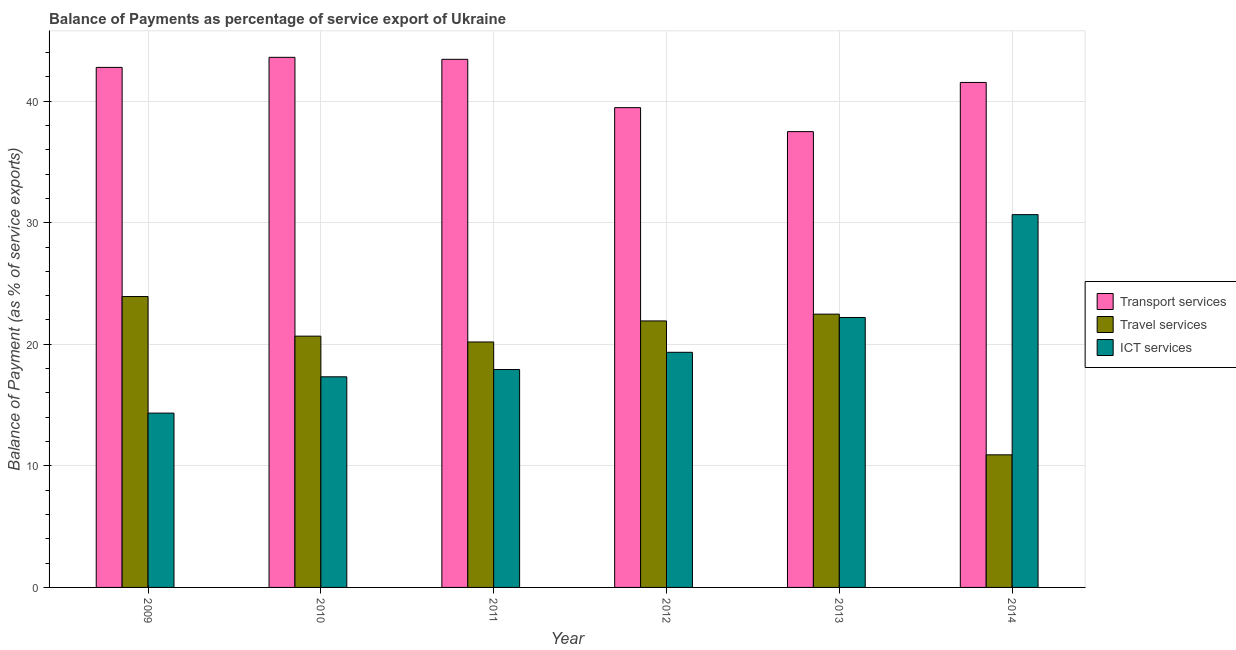How many different coloured bars are there?
Your answer should be very brief. 3. How many groups of bars are there?
Your answer should be very brief. 6. Are the number of bars per tick equal to the number of legend labels?
Offer a very short reply. Yes. How many bars are there on the 4th tick from the right?
Provide a short and direct response. 3. What is the label of the 6th group of bars from the left?
Your answer should be very brief. 2014. What is the balance of payment of travel services in 2014?
Offer a terse response. 10.91. Across all years, what is the maximum balance of payment of travel services?
Your response must be concise. 23.93. Across all years, what is the minimum balance of payment of ict services?
Offer a very short reply. 14.34. What is the total balance of payment of ict services in the graph?
Offer a very short reply. 121.79. What is the difference between the balance of payment of ict services in 2012 and that in 2013?
Your answer should be compact. -2.86. What is the difference between the balance of payment of transport services in 2014 and the balance of payment of travel services in 2009?
Ensure brevity in your answer.  -1.24. What is the average balance of payment of ict services per year?
Your answer should be compact. 20.3. In the year 2013, what is the difference between the balance of payment of travel services and balance of payment of transport services?
Offer a terse response. 0. What is the ratio of the balance of payment of travel services in 2012 to that in 2014?
Offer a very short reply. 2.01. Is the balance of payment of ict services in 2009 less than that in 2012?
Offer a very short reply. Yes. Is the difference between the balance of payment of travel services in 2011 and 2013 greater than the difference between the balance of payment of ict services in 2011 and 2013?
Keep it short and to the point. No. What is the difference between the highest and the second highest balance of payment of transport services?
Provide a succinct answer. 0.16. What is the difference between the highest and the lowest balance of payment of travel services?
Make the answer very short. 13.02. What does the 2nd bar from the left in 2012 represents?
Your response must be concise. Travel services. What does the 2nd bar from the right in 2014 represents?
Your answer should be very brief. Travel services. Is it the case that in every year, the sum of the balance of payment of transport services and balance of payment of travel services is greater than the balance of payment of ict services?
Ensure brevity in your answer.  Yes. How many bars are there?
Your answer should be very brief. 18. Are all the bars in the graph horizontal?
Provide a short and direct response. No. How many years are there in the graph?
Your answer should be compact. 6. What is the difference between two consecutive major ticks on the Y-axis?
Your answer should be very brief. 10. Are the values on the major ticks of Y-axis written in scientific E-notation?
Ensure brevity in your answer.  No. Does the graph contain any zero values?
Your answer should be very brief. No. Does the graph contain grids?
Offer a terse response. Yes. How many legend labels are there?
Offer a very short reply. 3. How are the legend labels stacked?
Your answer should be very brief. Vertical. What is the title of the graph?
Give a very brief answer. Balance of Payments as percentage of service export of Ukraine. Does "Financial account" appear as one of the legend labels in the graph?
Give a very brief answer. No. What is the label or title of the Y-axis?
Offer a terse response. Balance of Payment (as % of service exports). What is the Balance of Payment (as % of service exports) in Transport services in 2009?
Your answer should be very brief. 42.77. What is the Balance of Payment (as % of service exports) of Travel services in 2009?
Offer a terse response. 23.93. What is the Balance of Payment (as % of service exports) of ICT services in 2009?
Your response must be concise. 14.34. What is the Balance of Payment (as % of service exports) of Transport services in 2010?
Make the answer very short. 43.6. What is the Balance of Payment (as % of service exports) in Travel services in 2010?
Give a very brief answer. 20.67. What is the Balance of Payment (as % of service exports) of ICT services in 2010?
Ensure brevity in your answer.  17.32. What is the Balance of Payment (as % of service exports) of Transport services in 2011?
Keep it short and to the point. 43.44. What is the Balance of Payment (as % of service exports) in Travel services in 2011?
Provide a short and direct response. 20.19. What is the Balance of Payment (as % of service exports) in ICT services in 2011?
Offer a terse response. 17.92. What is the Balance of Payment (as % of service exports) of Transport services in 2012?
Your response must be concise. 39.46. What is the Balance of Payment (as % of service exports) in Travel services in 2012?
Keep it short and to the point. 21.92. What is the Balance of Payment (as % of service exports) in ICT services in 2012?
Keep it short and to the point. 19.34. What is the Balance of Payment (as % of service exports) in Transport services in 2013?
Your answer should be very brief. 37.49. What is the Balance of Payment (as % of service exports) in Travel services in 2013?
Give a very brief answer. 22.48. What is the Balance of Payment (as % of service exports) of ICT services in 2013?
Offer a very short reply. 22.2. What is the Balance of Payment (as % of service exports) of Transport services in 2014?
Offer a very short reply. 41.54. What is the Balance of Payment (as % of service exports) of Travel services in 2014?
Give a very brief answer. 10.91. What is the Balance of Payment (as % of service exports) in ICT services in 2014?
Your answer should be very brief. 30.66. Across all years, what is the maximum Balance of Payment (as % of service exports) in Transport services?
Your answer should be very brief. 43.6. Across all years, what is the maximum Balance of Payment (as % of service exports) of Travel services?
Offer a terse response. 23.93. Across all years, what is the maximum Balance of Payment (as % of service exports) of ICT services?
Give a very brief answer. 30.66. Across all years, what is the minimum Balance of Payment (as % of service exports) of Transport services?
Offer a terse response. 37.49. Across all years, what is the minimum Balance of Payment (as % of service exports) in Travel services?
Give a very brief answer. 10.91. Across all years, what is the minimum Balance of Payment (as % of service exports) in ICT services?
Provide a short and direct response. 14.34. What is the total Balance of Payment (as % of service exports) in Transport services in the graph?
Your answer should be compact. 248.31. What is the total Balance of Payment (as % of service exports) of Travel services in the graph?
Offer a terse response. 120.09. What is the total Balance of Payment (as % of service exports) in ICT services in the graph?
Your answer should be compact. 121.79. What is the difference between the Balance of Payment (as % of service exports) in Transport services in 2009 and that in 2010?
Offer a terse response. -0.83. What is the difference between the Balance of Payment (as % of service exports) in Travel services in 2009 and that in 2010?
Give a very brief answer. 3.26. What is the difference between the Balance of Payment (as % of service exports) in ICT services in 2009 and that in 2010?
Offer a terse response. -2.99. What is the difference between the Balance of Payment (as % of service exports) of Transport services in 2009 and that in 2011?
Your answer should be very brief. -0.66. What is the difference between the Balance of Payment (as % of service exports) in Travel services in 2009 and that in 2011?
Keep it short and to the point. 3.74. What is the difference between the Balance of Payment (as % of service exports) of ICT services in 2009 and that in 2011?
Your answer should be compact. -3.58. What is the difference between the Balance of Payment (as % of service exports) in Transport services in 2009 and that in 2012?
Provide a short and direct response. 3.31. What is the difference between the Balance of Payment (as % of service exports) of Travel services in 2009 and that in 2012?
Your response must be concise. 2.01. What is the difference between the Balance of Payment (as % of service exports) of ICT services in 2009 and that in 2012?
Ensure brevity in your answer.  -5. What is the difference between the Balance of Payment (as % of service exports) in Transport services in 2009 and that in 2013?
Offer a terse response. 5.28. What is the difference between the Balance of Payment (as % of service exports) in Travel services in 2009 and that in 2013?
Make the answer very short. 1.45. What is the difference between the Balance of Payment (as % of service exports) of ICT services in 2009 and that in 2013?
Ensure brevity in your answer.  -7.87. What is the difference between the Balance of Payment (as % of service exports) of Transport services in 2009 and that in 2014?
Offer a terse response. 1.24. What is the difference between the Balance of Payment (as % of service exports) of Travel services in 2009 and that in 2014?
Give a very brief answer. 13.02. What is the difference between the Balance of Payment (as % of service exports) in ICT services in 2009 and that in 2014?
Your answer should be compact. -16.32. What is the difference between the Balance of Payment (as % of service exports) of Transport services in 2010 and that in 2011?
Provide a short and direct response. 0.16. What is the difference between the Balance of Payment (as % of service exports) of Travel services in 2010 and that in 2011?
Ensure brevity in your answer.  0.48. What is the difference between the Balance of Payment (as % of service exports) in ICT services in 2010 and that in 2011?
Give a very brief answer. -0.6. What is the difference between the Balance of Payment (as % of service exports) of Transport services in 2010 and that in 2012?
Your answer should be very brief. 4.14. What is the difference between the Balance of Payment (as % of service exports) in Travel services in 2010 and that in 2012?
Offer a very short reply. -1.25. What is the difference between the Balance of Payment (as % of service exports) of ICT services in 2010 and that in 2012?
Your response must be concise. -2.02. What is the difference between the Balance of Payment (as % of service exports) in Transport services in 2010 and that in 2013?
Provide a succinct answer. 6.11. What is the difference between the Balance of Payment (as % of service exports) in Travel services in 2010 and that in 2013?
Your answer should be very brief. -1.81. What is the difference between the Balance of Payment (as % of service exports) of ICT services in 2010 and that in 2013?
Your response must be concise. -4.88. What is the difference between the Balance of Payment (as % of service exports) of Transport services in 2010 and that in 2014?
Keep it short and to the point. 2.07. What is the difference between the Balance of Payment (as % of service exports) in Travel services in 2010 and that in 2014?
Keep it short and to the point. 9.76. What is the difference between the Balance of Payment (as % of service exports) of ICT services in 2010 and that in 2014?
Offer a very short reply. -13.34. What is the difference between the Balance of Payment (as % of service exports) of Transport services in 2011 and that in 2012?
Make the answer very short. 3.98. What is the difference between the Balance of Payment (as % of service exports) of Travel services in 2011 and that in 2012?
Ensure brevity in your answer.  -1.73. What is the difference between the Balance of Payment (as % of service exports) of ICT services in 2011 and that in 2012?
Offer a very short reply. -1.42. What is the difference between the Balance of Payment (as % of service exports) in Transport services in 2011 and that in 2013?
Make the answer very short. 5.95. What is the difference between the Balance of Payment (as % of service exports) in Travel services in 2011 and that in 2013?
Give a very brief answer. -2.29. What is the difference between the Balance of Payment (as % of service exports) in ICT services in 2011 and that in 2013?
Give a very brief answer. -4.28. What is the difference between the Balance of Payment (as % of service exports) of Transport services in 2011 and that in 2014?
Offer a terse response. 1.9. What is the difference between the Balance of Payment (as % of service exports) of Travel services in 2011 and that in 2014?
Keep it short and to the point. 9.28. What is the difference between the Balance of Payment (as % of service exports) in ICT services in 2011 and that in 2014?
Offer a terse response. -12.74. What is the difference between the Balance of Payment (as % of service exports) in Transport services in 2012 and that in 2013?
Ensure brevity in your answer.  1.97. What is the difference between the Balance of Payment (as % of service exports) of Travel services in 2012 and that in 2013?
Your answer should be compact. -0.56. What is the difference between the Balance of Payment (as % of service exports) in ICT services in 2012 and that in 2013?
Offer a very short reply. -2.86. What is the difference between the Balance of Payment (as % of service exports) of Transport services in 2012 and that in 2014?
Your answer should be very brief. -2.07. What is the difference between the Balance of Payment (as % of service exports) of Travel services in 2012 and that in 2014?
Offer a very short reply. 11.01. What is the difference between the Balance of Payment (as % of service exports) in ICT services in 2012 and that in 2014?
Your answer should be compact. -11.32. What is the difference between the Balance of Payment (as % of service exports) of Transport services in 2013 and that in 2014?
Keep it short and to the point. -4.04. What is the difference between the Balance of Payment (as % of service exports) of Travel services in 2013 and that in 2014?
Offer a very short reply. 11.57. What is the difference between the Balance of Payment (as % of service exports) of ICT services in 2013 and that in 2014?
Your answer should be very brief. -8.46. What is the difference between the Balance of Payment (as % of service exports) of Transport services in 2009 and the Balance of Payment (as % of service exports) of Travel services in 2010?
Your answer should be compact. 22.11. What is the difference between the Balance of Payment (as % of service exports) of Transport services in 2009 and the Balance of Payment (as % of service exports) of ICT services in 2010?
Give a very brief answer. 25.45. What is the difference between the Balance of Payment (as % of service exports) in Travel services in 2009 and the Balance of Payment (as % of service exports) in ICT services in 2010?
Offer a very short reply. 6.6. What is the difference between the Balance of Payment (as % of service exports) of Transport services in 2009 and the Balance of Payment (as % of service exports) of Travel services in 2011?
Keep it short and to the point. 22.59. What is the difference between the Balance of Payment (as % of service exports) of Transport services in 2009 and the Balance of Payment (as % of service exports) of ICT services in 2011?
Keep it short and to the point. 24.85. What is the difference between the Balance of Payment (as % of service exports) in Travel services in 2009 and the Balance of Payment (as % of service exports) in ICT services in 2011?
Your answer should be compact. 6. What is the difference between the Balance of Payment (as % of service exports) in Transport services in 2009 and the Balance of Payment (as % of service exports) in Travel services in 2012?
Make the answer very short. 20.85. What is the difference between the Balance of Payment (as % of service exports) in Transport services in 2009 and the Balance of Payment (as % of service exports) in ICT services in 2012?
Provide a short and direct response. 23.43. What is the difference between the Balance of Payment (as % of service exports) of Travel services in 2009 and the Balance of Payment (as % of service exports) of ICT services in 2012?
Your answer should be very brief. 4.59. What is the difference between the Balance of Payment (as % of service exports) of Transport services in 2009 and the Balance of Payment (as % of service exports) of Travel services in 2013?
Offer a very short reply. 20.3. What is the difference between the Balance of Payment (as % of service exports) of Transport services in 2009 and the Balance of Payment (as % of service exports) of ICT services in 2013?
Give a very brief answer. 20.57. What is the difference between the Balance of Payment (as % of service exports) in Travel services in 2009 and the Balance of Payment (as % of service exports) in ICT services in 2013?
Give a very brief answer. 1.72. What is the difference between the Balance of Payment (as % of service exports) in Transport services in 2009 and the Balance of Payment (as % of service exports) in Travel services in 2014?
Offer a very short reply. 31.87. What is the difference between the Balance of Payment (as % of service exports) in Transport services in 2009 and the Balance of Payment (as % of service exports) in ICT services in 2014?
Ensure brevity in your answer.  12.11. What is the difference between the Balance of Payment (as % of service exports) in Travel services in 2009 and the Balance of Payment (as % of service exports) in ICT services in 2014?
Your answer should be very brief. -6.74. What is the difference between the Balance of Payment (as % of service exports) of Transport services in 2010 and the Balance of Payment (as % of service exports) of Travel services in 2011?
Offer a very short reply. 23.41. What is the difference between the Balance of Payment (as % of service exports) of Transport services in 2010 and the Balance of Payment (as % of service exports) of ICT services in 2011?
Your answer should be very brief. 25.68. What is the difference between the Balance of Payment (as % of service exports) of Travel services in 2010 and the Balance of Payment (as % of service exports) of ICT services in 2011?
Your answer should be compact. 2.75. What is the difference between the Balance of Payment (as % of service exports) in Transport services in 2010 and the Balance of Payment (as % of service exports) in Travel services in 2012?
Provide a short and direct response. 21.68. What is the difference between the Balance of Payment (as % of service exports) of Transport services in 2010 and the Balance of Payment (as % of service exports) of ICT services in 2012?
Offer a very short reply. 24.26. What is the difference between the Balance of Payment (as % of service exports) in Travel services in 2010 and the Balance of Payment (as % of service exports) in ICT services in 2012?
Your answer should be compact. 1.33. What is the difference between the Balance of Payment (as % of service exports) of Transport services in 2010 and the Balance of Payment (as % of service exports) of Travel services in 2013?
Offer a very short reply. 21.12. What is the difference between the Balance of Payment (as % of service exports) of Transport services in 2010 and the Balance of Payment (as % of service exports) of ICT services in 2013?
Provide a succinct answer. 21.4. What is the difference between the Balance of Payment (as % of service exports) of Travel services in 2010 and the Balance of Payment (as % of service exports) of ICT services in 2013?
Ensure brevity in your answer.  -1.54. What is the difference between the Balance of Payment (as % of service exports) of Transport services in 2010 and the Balance of Payment (as % of service exports) of Travel services in 2014?
Ensure brevity in your answer.  32.7. What is the difference between the Balance of Payment (as % of service exports) of Transport services in 2010 and the Balance of Payment (as % of service exports) of ICT services in 2014?
Provide a short and direct response. 12.94. What is the difference between the Balance of Payment (as % of service exports) of Travel services in 2010 and the Balance of Payment (as % of service exports) of ICT services in 2014?
Provide a succinct answer. -9.99. What is the difference between the Balance of Payment (as % of service exports) of Transport services in 2011 and the Balance of Payment (as % of service exports) of Travel services in 2012?
Ensure brevity in your answer.  21.52. What is the difference between the Balance of Payment (as % of service exports) in Transport services in 2011 and the Balance of Payment (as % of service exports) in ICT services in 2012?
Give a very brief answer. 24.1. What is the difference between the Balance of Payment (as % of service exports) of Travel services in 2011 and the Balance of Payment (as % of service exports) of ICT services in 2012?
Ensure brevity in your answer.  0.85. What is the difference between the Balance of Payment (as % of service exports) of Transport services in 2011 and the Balance of Payment (as % of service exports) of Travel services in 2013?
Provide a short and direct response. 20.96. What is the difference between the Balance of Payment (as % of service exports) in Transport services in 2011 and the Balance of Payment (as % of service exports) in ICT services in 2013?
Offer a terse response. 21.23. What is the difference between the Balance of Payment (as % of service exports) in Travel services in 2011 and the Balance of Payment (as % of service exports) in ICT services in 2013?
Provide a short and direct response. -2.02. What is the difference between the Balance of Payment (as % of service exports) in Transport services in 2011 and the Balance of Payment (as % of service exports) in Travel services in 2014?
Your answer should be compact. 32.53. What is the difference between the Balance of Payment (as % of service exports) of Transport services in 2011 and the Balance of Payment (as % of service exports) of ICT services in 2014?
Make the answer very short. 12.78. What is the difference between the Balance of Payment (as % of service exports) of Travel services in 2011 and the Balance of Payment (as % of service exports) of ICT services in 2014?
Provide a succinct answer. -10.47. What is the difference between the Balance of Payment (as % of service exports) of Transport services in 2012 and the Balance of Payment (as % of service exports) of Travel services in 2013?
Give a very brief answer. 16.98. What is the difference between the Balance of Payment (as % of service exports) of Transport services in 2012 and the Balance of Payment (as % of service exports) of ICT services in 2013?
Offer a very short reply. 17.26. What is the difference between the Balance of Payment (as % of service exports) of Travel services in 2012 and the Balance of Payment (as % of service exports) of ICT services in 2013?
Keep it short and to the point. -0.28. What is the difference between the Balance of Payment (as % of service exports) of Transport services in 2012 and the Balance of Payment (as % of service exports) of Travel services in 2014?
Give a very brief answer. 28.56. What is the difference between the Balance of Payment (as % of service exports) of Transport services in 2012 and the Balance of Payment (as % of service exports) of ICT services in 2014?
Offer a terse response. 8.8. What is the difference between the Balance of Payment (as % of service exports) in Travel services in 2012 and the Balance of Payment (as % of service exports) in ICT services in 2014?
Provide a succinct answer. -8.74. What is the difference between the Balance of Payment (as % of service exports) of Transport services in 2013 and the Balance of Payment (as % of service exports) of Travel services in 2014?
Offer a terse response. 26.59. What is the difference between the Balance of Payment (as % of service exports) in Transport services in 2013 and the Balance of Payment (as % of service exports) in ICT services in 2014?
Ensure brevity in your answer.  6.83. What is the difference between the Balance of Payment (as % of service exports) of Travel services in 2013 and the Balance of Payment (as % of service exports) of ICT services in 2014?
Offer a very short reply. -8.18. What is the average Balance of Payment (as % of service exports) in Transport services per year?
Keep it short and to the point. 41.38. What is the average Balance of Payment (as % of service exports) in Travel services per year?
Your answer should be very brief. 20.01. What is the average Balance of Payment (as % of service exports) of ICT services per year?
Your response must be concise. 20.3. In the year 2009, what is the difference between the Balance of Payment (as % of service exports) of Transport services and Balance of Payment (as % of service exports) of Travel services?
Keep it short and to the point. 18.85. In the year 2009, what is the difference between the Balance of Payment (as % of service exports) of Transport services and Balance of Payment (as % of service exports) of ICT services?
Provide a short and direct response. 28.44. In the year 2009, what is the difference between the Balance of Payment (as % of service exports) of Travel services and Balance of Payment (as % of service exports) of ICT services?
Ensure brevity in your answer.  9.59. In the year 2010, what is the difference between the Balance of Payment (as % of service exports) of Transport services and Balance of Payment (as % of service exports) of Travel services?
Ensure brevity in your answer.  22.93. In the year 2010, what is the difference between the Balance of Payment (as % of service exports) in Transport services and Balance of Payment (as % of service exports) in ICT services?
Give a very brief answer. 26.28. In the year 2010, what is the difference between the Balance of Payment (as % of service exports) of Travel services and Balance of Payment (as % of service exports) of ICT services?
Your response must be concise. 3.34. In the year 2011, what is the difference between the Balance of Payment (as % of service exports) of Transport services and Balance of Payment (as % of service exports) of Travel services?
Your answer should be very brief. 23.25. In the year 2011, what is the difference between the Balance of Payment (as % of service exports) of Transport services and Balance of Payment (as % of service exports) of ICT services?
Offer a very short reply. 25.52. In the year 2011, what is the difference between the Balance of Payment (as % of service exports) of Travel services and Balance of Payment (as % of service exports) of ICT services?
Provide a succinct answer. 2.27. In the year 2012, what is the difference between the Balance of Payment (as % of service exports) in Transport services and Balance of Payment (as % of service exports) in Travel services?
Make the answer very short. 17.54. In the year 2012, what is the difference between the Balance of Payment (as % of service exports) of Transport services and Balance of Payment (as % of service exports) of ICT services?
Your answer should be compact. 20.12. In the year 2012, what is the difference between the Balance of Payment (as % of service exports) of Travel services and Balance of Payment (as % of service exports) of ICT services?
Provide a succinct answer. 2.58. In the year 2013, what is the difference between the Balance of Payment (as % of service exports) of Transport services and Balance of Payment (as % of service exports) of Travel services?
Give a very brief answer. 15.01. In the year 2013, what is the difference between the Balance of Payment (as % of service exports) of Transport services and Balance of Payment (as % of service exports) of ICT services?
Keep it short and to the point. 15.29. In the year 2013, what is the difference between the Balance of Payment (as % of service exports) of Travel services and Balance of Payment (as % of service exports) of ICT services?
Keep it short and to the point. 0.27. In the year 2014, what is the difference between the Balance of Payment (as % of service exports) of Transport services and Balance of Payment (as % of service exports) of Travel services?
Your response must be concise. 30.63. In the year 2014, what is the difference between the Balance of Payment (as % of service exports) in Transport services and Balance of Payment (as % of service exports) in ICT services?
Give a very brief answer. 10.87. In the year 2014, what is the difference between the Balance of Payment (as % of service exports) in Travel services and Balance of Payment (as % of service exports) in ICT services?
Your response must be concise. -19.76. What is the ratio of the Balance of Payment (as % of service exports) in Transport services in 2009 to that in 2010?
Offer a very short reply. 0.98. What is the ratio of the Balance of Payment (as % of service exports) of Travel services in 2009 to that in 2010?
Keep it short and to the point. 1.16. What is the ratio of the Balance of Payment (as % of service exports) of ICT services in 2009 to that in 2010?
Make the answer very short. 0.83. What is the ratio of the Balance of Payment (as % of service exports) of Transport services in 2009 to that in 2011?
Make the answer very short. 0.98. What is the ratio of the Balance of Payment (as % of service exports) of Travel services in 2009 to that in 2011?
Offer a very short reply. 1.19. What is the ratio of the Balance of Payment (as % of service exports) in Transport services in 2009 to that in 2012?
Make the answer very short. 1.08. What is the ratio of the Balance of Payment (as % of service exports) in Travel services in 2009 to that in 2012?
Give a very brief answer. 1.09. What is the ratio of the Balance of Payment (as % of service exports) of ICT services in 2009 to that in 2012?
Provide a succinct answer. 0.74. What is the ratio of the Balance of Payment (as % of service exports) in Transport services in 2009 to that in 2013?
Your response must be concise. 1.14. What is the ratio of the Balance of Payment (as % of service exports) in Travel services in 2009 to that in 2013?
Give a very brief answer. 1.06. What is the ratio of the Balance of Payment (as % of service exports) in ICT services in 2009 to that in 2013?
Your answer should be very brief. 0.65. What is the ratio of the Balance of Payment (as % of service exports) of Transport services in 2009 to that in 2014?
Ensure brevity in your answer.  1.03. What is the ratio of the Balance of Payment (as % of service exports) of Travel services in 2009 to that in 2014?
Your answer should be compact. 2.19. What is the ratio of the Balance of Payment (as % of service exports) in ICT services in 2009 to that in 2014?
Provide a succinct answer. 0.47. What is the ratio of the Balance of Payment (as % of service exports) in Travel services in 2010 to that in 2011?
Your answer should be compact. 1.02. What is the ratio of the Balance of Payment (as % of service exports) in ICT services in 2010 to that in 2011?
Give a very brief answer. 0.97. What is the ratio of the Balance of Payment (as % of service exports) of Transport services in 2010 to that in 2012?
Your response must be concise. 1.1. What is the ratio of the Balance of Payment (as % of service exports) of Travel services in 2010 to that in 2012?
Your answer should be compact. 0.94. What is the ratio of the Balance of Payment (as % of service exports) in ICT services in 2010 to that in 2012?
Your response must be concise. 0.9. What is the ratio of the Balance of Payment (as % of service exports) of Transport services in 2010 to that in 2013?
Offer a very short reply. 1.16. What is the ratio of the Balance of Payment (as % of service exports) of Travel services in 2010 to that in 2013?
Keep it short and to the point. 0.92. What is the ratio of the Balance of Payment (as % of service exports) of ICT services in 2010 to that in 2013?
Make the answer very short. 0.78. What is the ratio of the Balance of Payment (as % of service exports) in Transport services in 2010 to that in 2014?
Provide a succinct answer. 1.05. What is the ratio of the Balance of Payment (as % of service exports) of Travel services in 2010 to that in 2014?
Your answer should be very brief. 1.9. What is the ratio of the Balance of Payment (as % of service exports) in ICT services in 2010 to that in 2014?
Your response must be concise. 0.56. What is the ratio of the Balance of Payment (as % of service exports) in Transport services in 2011 to that in 2012?
Provide a short and direct response. 1.1. What is the ratio of the Balance of Payment (as % of service exports) in Travel services in 2011 to that in 2012?
Offer a very short reply. 0.92. What is the ratio of the Balance of Payment (as % of service exports) of ICT services in 2011 to that in 2012?
Provide a succinct answer. 0.93. What is the ratio of the Balance of Payment (as % of service exports) of Transport services in 2011 to that in 2013?
Keep it short and to the point. 1.16. What is the ratio of the Balance of Payment (as % of service exports) of Travel services in 2011 to that in 2013?
Ensure brevity in your answer.  0.9. What is the ratio of the Balance of Payment (as % of service exports) of ICT services in 2011 to that in 2013?
Your answer should be compact. 0.81. What is the ratio of the Balance of Payment (as % of service exports) of Transport services in 2011 to that in 2014?
Provide a short and direct response. 1.05. What is the ratio of the Balance of Payment (as % of service exports) in Travel services in 2011 to that in 2014?
Keep it short and to the point. 1.85. What is the ratio of the Balance of Payment (as % of service exports) of ICT services in 2011 to that in 2014?
Offer a terse response. 0.58. What is the ratio of the Balance of Payment (as % of service exports) in Transport services in 2012 to that in 2013?
Make the answer very short. 1.05. What is the ratio of the Balance of Payment (as % of service exports) in Travel services in 2012 to that in 2013?
Offer a terse response. 0.98. What is the ratio of the Balance of Payment (as % of service exports) of ICT services in 2012 to that in 2013?
Make the answer very short. 0.87. What is the ratio of the Balance of Payment (as % of service exports) in Transport services in 2012 to that in 2014?
Ensure brevity in your answer.  0.95. What is the ratio of the Balance of Payment (as % of service exports) of Travel services in 2012 to that in 2014?
Give a very brief answer. 2.01. What is the ratio of the Balance of Payment (as % of service exports) of ICT services in 2012 to that in 2014?
Offer a very short reply. 0.63. What is the ratio of the Balance of Payment (as % of service exports) of Transport services in 2013 to that in 2014?
Your answer should be very brief. 0.9. What is the ratio of the Balance of Payment (as % of service exports) of Travel services in 2013 to that in 2014?
Provide a succinct answer. 2.06. What is the ratio of the Balance of Payment (as % of service exports) in ICT services in 2013 to that in 2014?
Provide a short and direct response. 0.72. What is the difference between the highest and the second highest Balance of Payment (as % of service exports) in Transport services?
Keep it short and to the point. 0.16. What is the difference between the highest and the second highest Balance of Payment (as % of service exports) of Travel services?
Your response must be concise. 1.45. What is the difference between the highest and the second highest Balance of Payment (as % of service exports) of ICT services?
Give a very brief answer. 8.46. What is the difference between the highest and the lowest Balance of Payment (as % of service exports) in Transport services?
Offer a terse response. 6.11. What is the difference between the highest and the lowest Balance of Payment (as % of service exports) of Travel services?
Provide a short and direct response. 13.02. What is the difference between the highest and the lowest Balance of Payment (as % of service exports) in ICT services?
Your answer should be very brief. 16.32. 